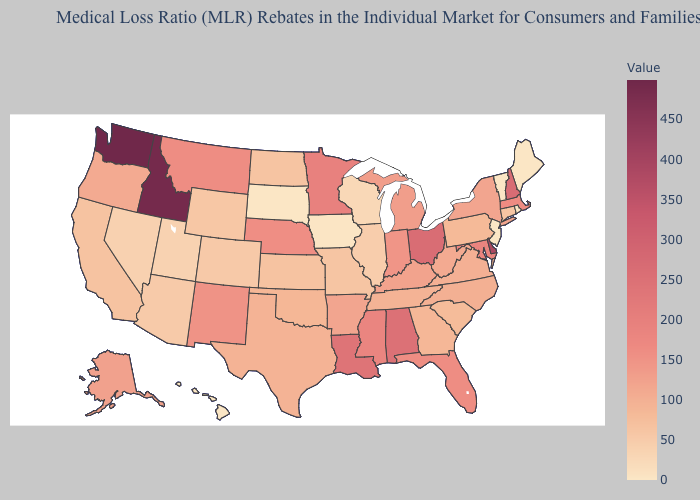Does the map have missing data?
Be succinct. No. Does Mississippi have the lowest value in the USA?
Short answer required. No. Among the states that border Texas , which have the lowest value?
Concise answer only. Oklahoma. Does South Carolina have the lowest value in the South?
Answer briefly. Yes. Does Maryland have a lower value than Idaho?
Write a very short answer. Yes. Which states have the lowest value in the Northeast?
Be succinct. Maine, New Jersey, Rhode Island, Vermont. Among the states that border California , which have the highest value?
Answer briefly. Oregon. Is the legend a continuous bar?
Short answer required. Yes. Among the states that border Ohio , which have the highest value?
Concise answer only. Indiana. Which states hav the highest value in the West?
Be succinct. Washington. 